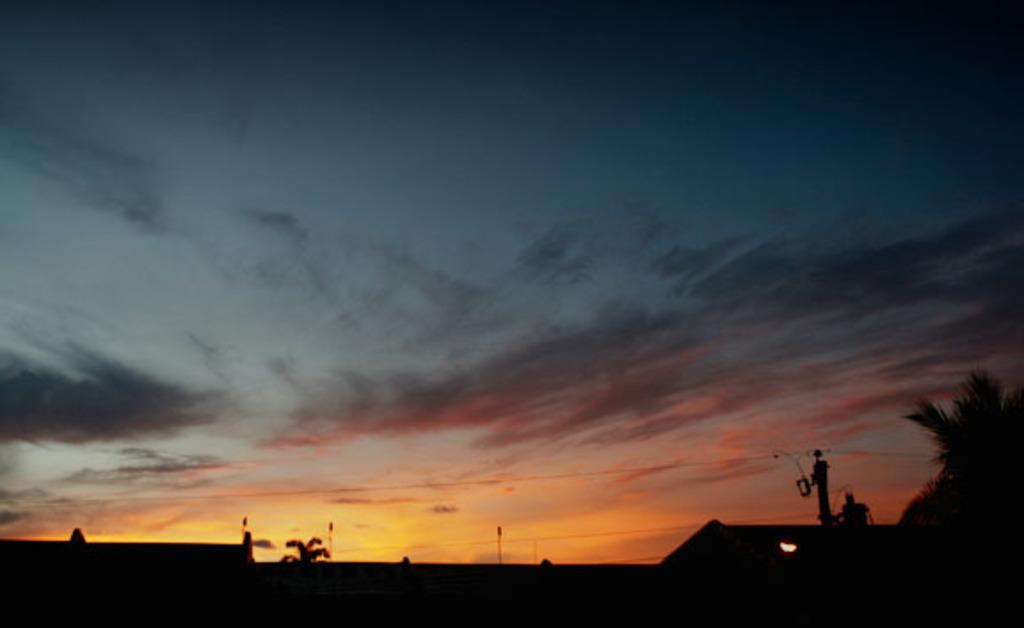What structure is partially visible in the image? There is a part of a house in the image. What is located beside the house? There is a pole beside the house. What type of tree can be seen in the image? There is a part of a coconut tree in the image. What is the color of the background in the image? The image has a dark background. What can be seen in the sky in the background? The sky with clouds is visible in the background. What type of government approval is required for the camp in the image? There is no camp present in the image, so the question of government approval is not applicable. 